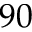<formula> <loc_0><loc_0><loc_500><loc_500>9 0</formula> 